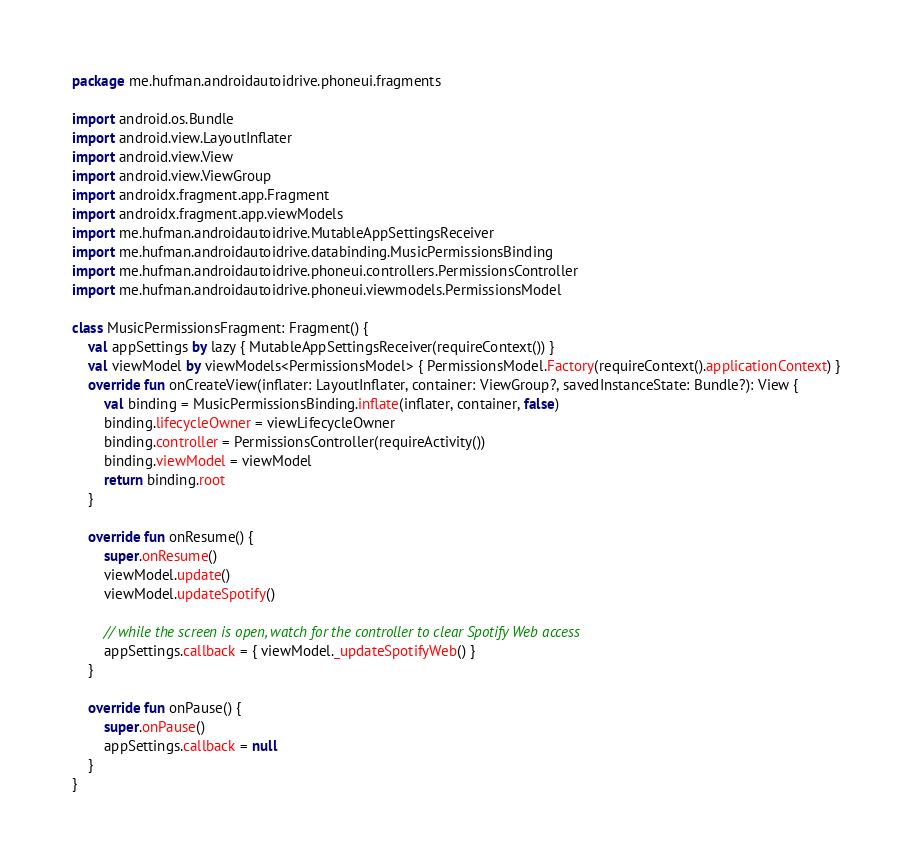Convert code to text. <code><loc_0><loc_0><loc_500><loc_500><_Kotlin_>package me.hufman.androidautoidrive.phoneui.fragments

import android.os.Bundle
import android.view.LayoutInflater
import android.view.View
import android.view.ViewGroup
import androidx.fragment.app.Fragment
import androidx.fragment.app.viewModels
import me.hufman.androidautoidrive.MutableAppSettingsReceiver
import me.hufman.androidautoidrive.databinding.MusicPermissionsBinding
import me.hufman.androidautoidrive.phoneui.controllers.PermissionsController
import me.hufman.androidautoidrive.phoneui.viewmodels.PermissionsModel

class MusicPermissionsFragment: Fragment() {
	val appSettings by lazy { MutableAppSettingsReceiver(requireContext()) }
	val viewModel by viewModels<PermissionsModel> { PermissionsModel.Factory(requireContext().applicationContext) }
	override fun onCreateView(inflater: LayoutInflater, container: ViewGroup?, savedInstanceState: Bundle?): View {
		val binding = MusicPermissionsBinding.inflate(inflater, container, false)
		binding.lifecycleOwner = viewLifecycleOwner
		binding.controller = PermissionsController(requireActivity())
		binding.viewModel = viewModel
		return binding.root
	}

	override fun onResume() {
		super.onResume()
		viewModel.update()
		viewModel.updateSpotify()

		// while the screen is open, watch for the controller to clear Spotify Web access
		appSettings.callback = { viewModel._updateSpotifyWeb() }
	}

	override fun onPause() {
		super.onPause()
		appSettings.callback = null
	}
}</code> 